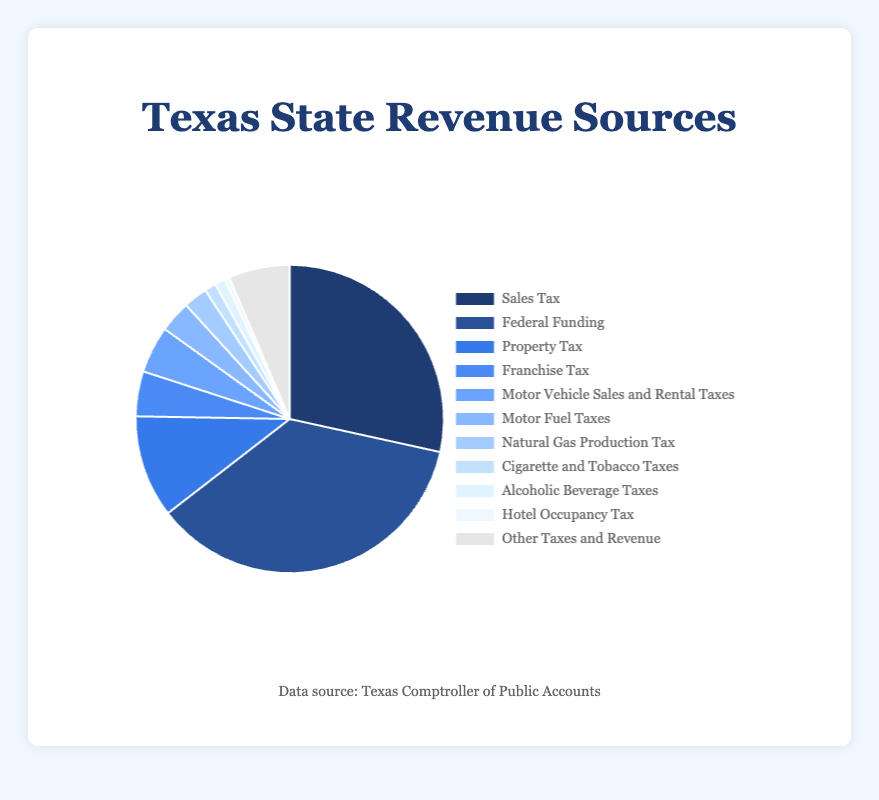What percentage of Texas state revenue comes from Sales Tax? Look for the percentage labeled "Sales Tax" in the figure. It is 28.3%.
Answer: 28.3% Which revenue source contributes the highest percentage to Texas state revenue? Identify the segment with the largest percentage value. It is "Federal Funding" with 35.9%.
Answer: Federal Funding What is the combined percentage of "Sales Tax" and "Property Tax"? Sum the percentages for "Sales Tax" (28.3%) and "Property Tax" (10.7%). The combined percentage is 28.3% + 10.7% = 39%.
Answer: 39% How does "Motor Vehicle Sales and Rental Taxes" compare to "Franchise Tax" in terms of percentage contribution? Compare the percentages of "Motor Vehicle Sales and Rental Taxes" (4.9%) and "Franchise Tax" (4.7%). "Motor Vehicle Sales and Rental Taxes" is slightly higher.
Answer: Motor Vehicle Sales and Rental Taxes is higher Which sources contribute to less than 5% of the state revenue? Identify all segments with percentages less than 5%: Franchise Tax (4.7%), Motor Vehicle Sales and Rental Taxes (4.9%), Motor Fuel Taxes (3.3%), Natural Gas Production Tax (2.5%), Cigarette and Tobacco Taxes (1.2%), Alcoholic Beverage Taxes (1.1%), and Hotel Occupancy Tax (0.5%).
Answer: Franchise Tax, Motor Vehicle Sales and Rental Taxes, Motor Fuel Taxes, Natural Gas Production Tax, Cigarette and Tobacco Taxes, Alcoholic Beverage Taxes, Hotel Occupancy Tax How does the percentage contribution of "Natural Gas Production Tax" compare to "Hotel Occupancy Tax"? Compare the percentages of "Natural Gas Production Tax" (2.5%) and "Hotel Occupancy Tax" (0.5%). "Natural Gas Production Tax" is higher.
Answer: Natural Gas Production Tax is higher What is the total percentage of revenue collected from sources contributing less than 3% each? Add the percentages for "Natural Gas Production Tax" (2.5%), "Cigarette and Tobacco Taxes" (1.2%), "Alcoholic Beverage Taxes" (1.1%), and "Hotel Occupancy Tax" (0.5%). The total is 2.5% + 1.2% + 1.1% + 0.5% = 5.3%.
Answer: 5.3% What is the percentage difference between "Federal Funding" and "Property Tax"? Subtract the percentage of "Property Tax" (10.7%) from "Federal Funding" (35.9%). The difference is 35.9% - 10.7% = 25.2%.
Answer: 25.2% If Texas decided to double the revenue collected from "Hotel Occupancy Tax," what would be its new contribution percentage? Double the percentage of "Hotel Occupancy Tax" (0.5%) to find the new contribution. The new percentage would be 0.5% × 2 = 1%.
Answer: 1% Which revenue source has the closest contribution percentage to 5%? Compare the percentages and identify the one closest to 5%, which is "Motor Vehicle Sales and Rental Taxes" at 4.9%.
Answer: Motor Vehicle Sales and Rental Taxes 